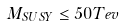Convert formula to latex. <formula><loc_0><loc_0><loc_500><loc_500>M _ { S U S Y } \leq 5 0 T e v</formula> 